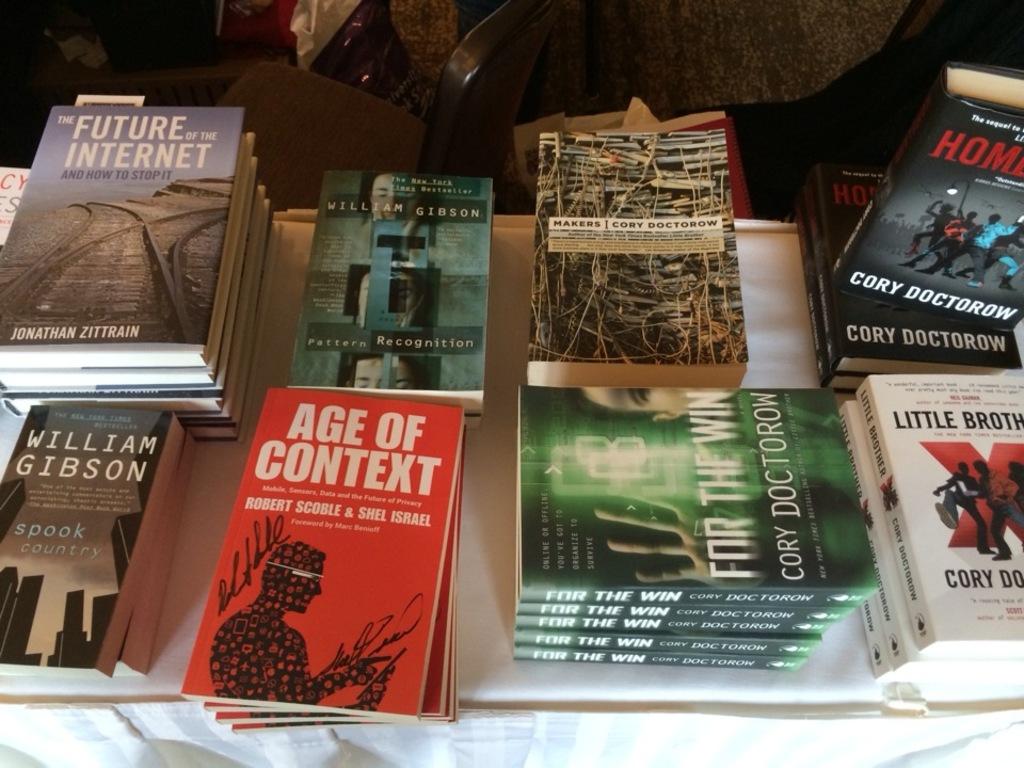What is the name of the red book?
Give a very brief answer. Age of context. 